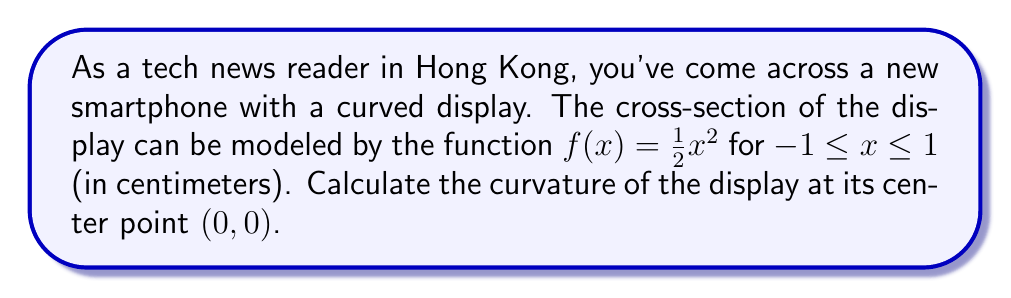Solve this math problem. To calculate the curvature at the center point, we'll follow these steps:

1. Recall the formula for curvature:
   $$\kappa = \frac{|f''(x)|}{(1 + [f'(x)]^2)^{3/2}}$$

2. Find the first derivative $f'(x)$:
   $$f'(x) = x$$

3. Find the second derivative $f''(x)$:
   $$f''(x) = 1$$

4. Evaluate $f'(x)$ and $f''(x)$ at $x=0$:
   $$f'(0) = 0$$
   $$f''(0) = 1$$

5. Substitute these values into the curvature formula:
   $$\kappa = \frac{|1|}{(1 + [0]^2)^{3/2}} = \frac{1}{1^{3/2}} = 1$$

Therefore, the curvature at the center point $(0,0)$ is 1 cm^(-1).
Answer: $1$ cm$^{-1}$ 